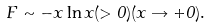Convert formula to latex. <formula><loc_0><loc_0><loc_500><loc_500>F \sim - x \ln x ( > 0 ) ( x \rightarrow + 0 ) .</formula> 